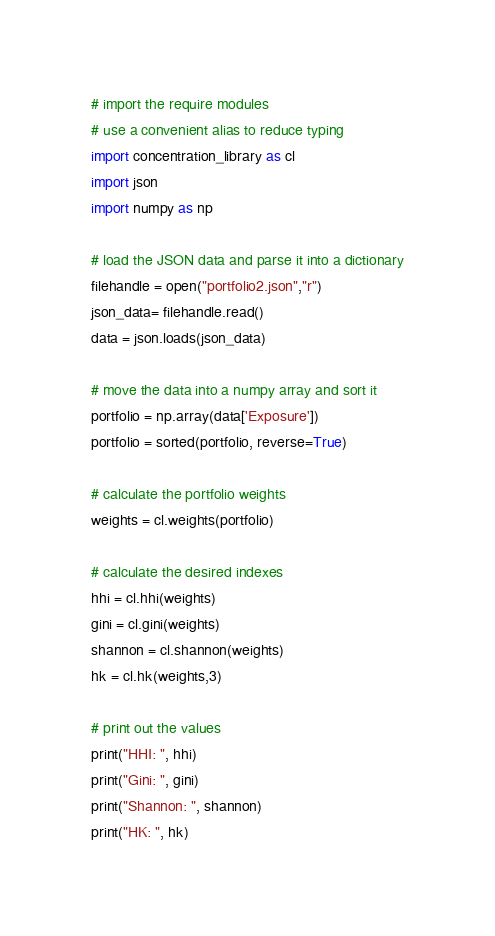<code> <loc_0><loc_0><loc_500><loc_500><_Python_>
# import the require modules
# use a convenient alias to reduce typing
import concentration_library as cl
import json
import numpy as np

# load the JSON data and parse it into a dictionary
filehandle = open("portfolio2.json","r")
json_data= filehandle.read()
data = json.loads(json_data)

# move the data into a numpy array and sort it
portfolio = np.array(data['Exposure'])
portfolio = sorted(portfolio, reverse=True)

# calculate the portfolio weights
weights = cl.weights(portfolio)

# calculate the desired indexes
hhi = cl.hhi(weights)
gini = cl.gini(weights)
shannon = cl.shannon(weights)
hk = cl.hk(weights,3)

# print out the values
print("HHI: ", hhi)
print("Gini: ", gini)
print("Shannon: ", shannon)
print("HK: ", hk)</code> 